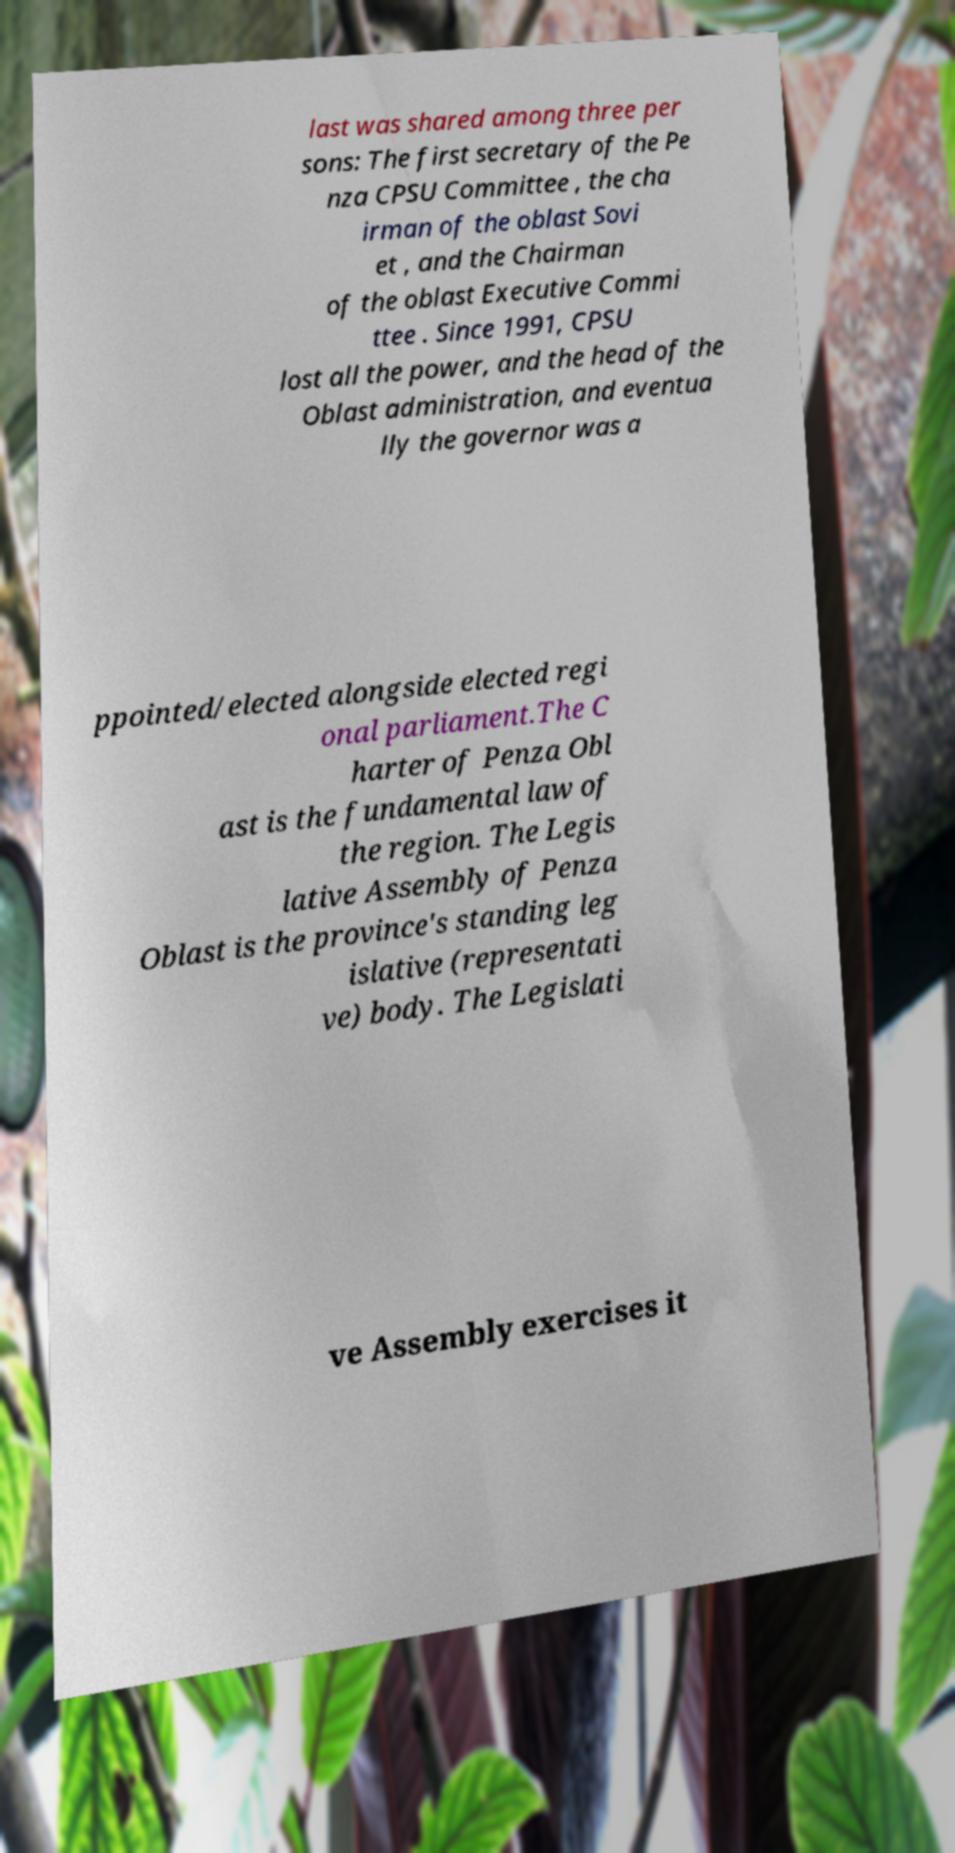Could you assist in decoding the text presented in this image and type it out clearly? last was shared among three per sons: The first secretary of the Pe nza CPSU Committee , the cha irman of the oblast Sovi et , and the Chairman of the oblast Executive Commi ttee . Since 1991, CPSU lost all the power, and the head of the Oblast administration, and eventua lly the governor was a ppointed/elected alongside elected regi onal parliament.The C harter of Penza Obl ast is the fundamental law of the region. The Legis lative Assembly of Penza Oblast is the province's standing leg islative (representati ve) body. The Legislati ve Assembly exercises it 